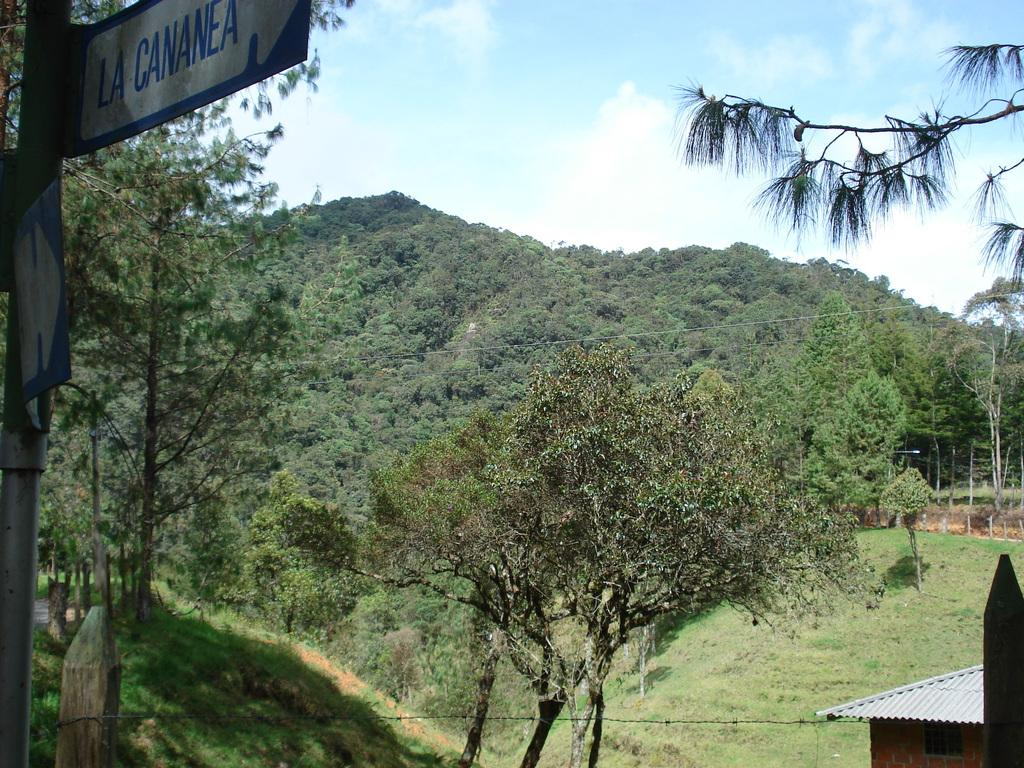What is located on the left side of the image? There is a board on the left side of the image. What can be seen in the middle of the image? There are trees in the middle of the image. What type of structure is visible in the bottom right-hand side of the image? There appears to be a shed in the bottom right-hand side of the image. What is visible at the top of the image? The sky is visible at the top of the image. What verse can be heard being recited in the image? There is no indication of any verse being recited in the image. What type of net is visible in the image? There is no net present in the image. 